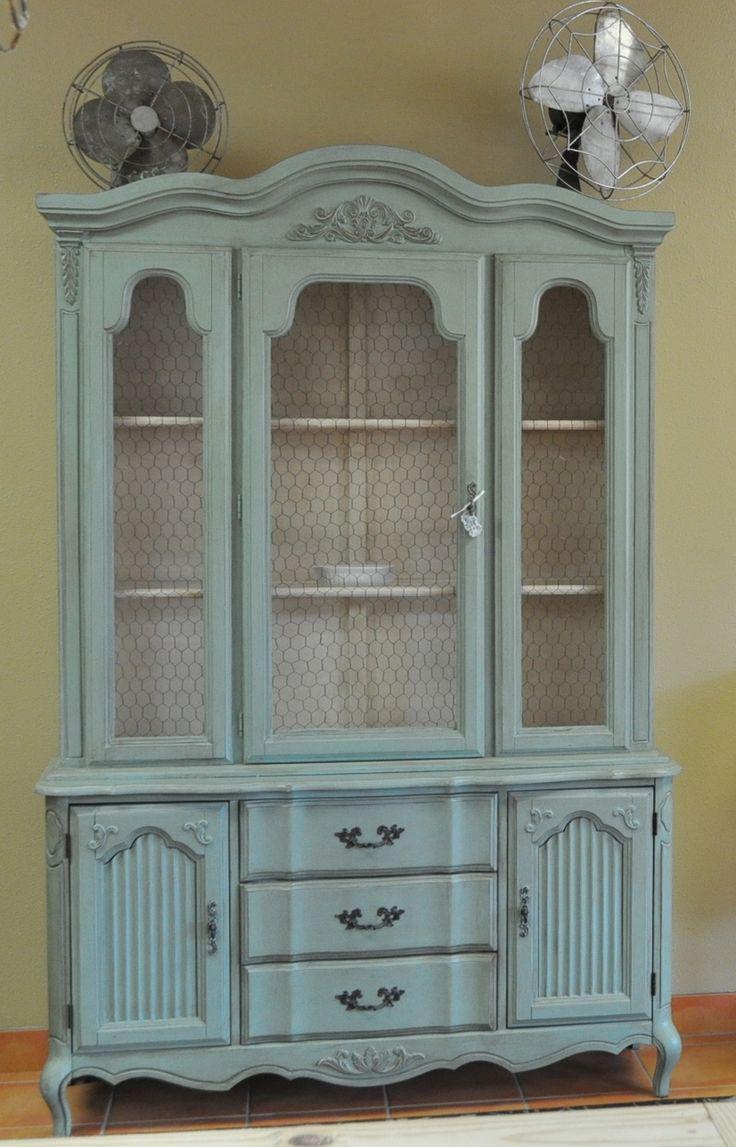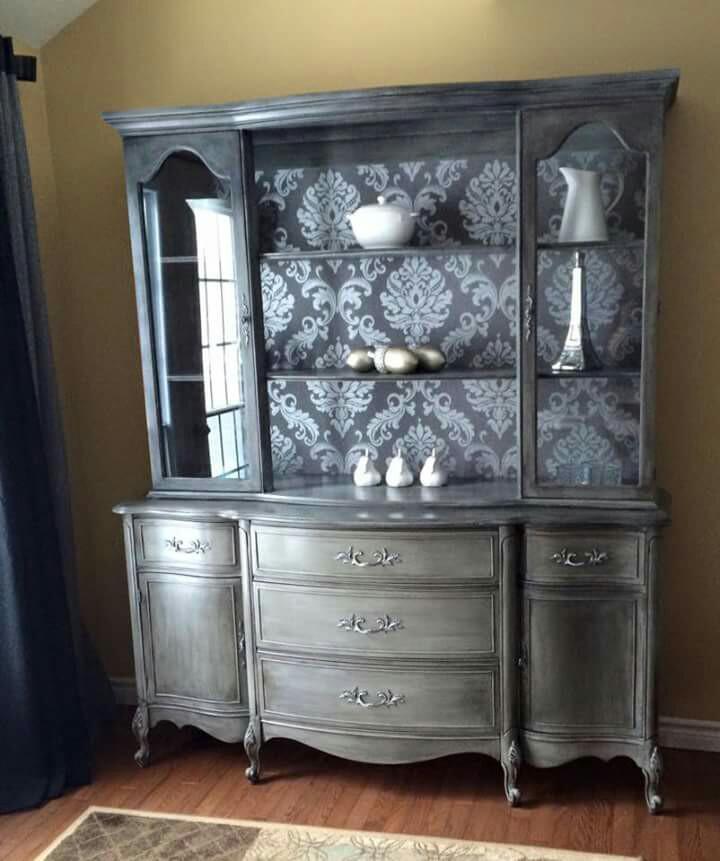The first image is the image on the left, the second image is the image on the right. For the images displayed, is the sentence "Two painted hutches both stand on legs with no glass in the bottom section, but are different colors, and one has a top curve design, while the other is flat on top." factually correct? Answer yes or no. Yes. The first image is the image on the left, the second image is the image on the right. Given the left and right images, does the statement "The cabinet in the left photo has a blue finish." hold true? Answer yes or no. Yes. 